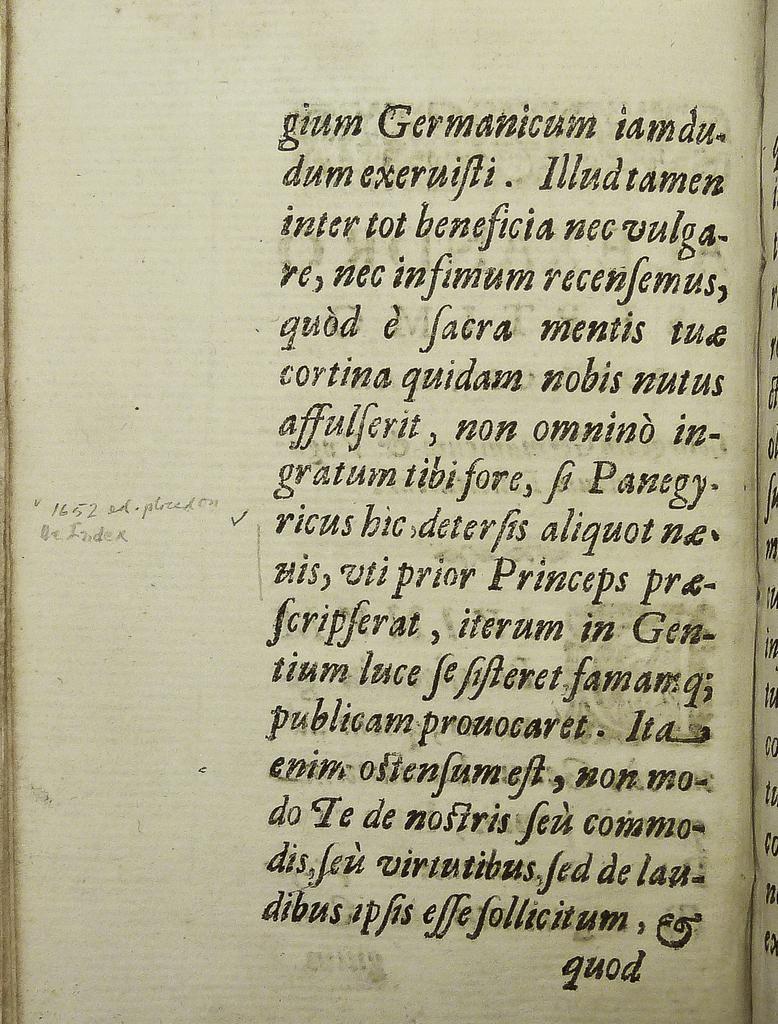Please provide a concise description of this image. In the image I can see a paper on which there is some text. 